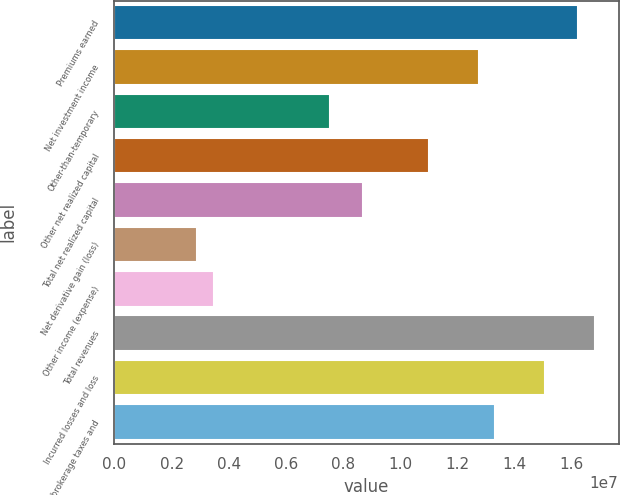<chart> <loc_0><loc_0><loc_500><loc_500><bar_chart><fcel>Premiums earned<fcel>Net investment income<fcel>Other-than-temporary<fcel>Other net realized capital<fcel>Total net realized capital<fcel>Net derivative gain (loss)<fcel>Other income (expense)<fcel>Total revenues<fcel>Incurred losses and loss<fcel>Commission brokerage taxes and<nl><fcel>1.62136e+07<fcel>1.27393e+07<fcel>7.52776e+06<fcel>1.10021e+07<fcel>8.68588e+06<fcel>2.8953e+06<fcel>3.47435e+06<fcel>1.67927e+07<fcel>1.50555e+07<fcel>1.33184e+07<nl></chart> 